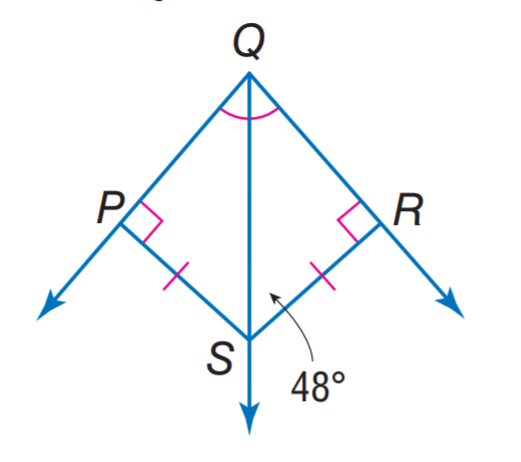Question: Find m \angle P Q S.
Choices:
A. 36
B. 42
C. 48
D. 63
Answer with the letter. Answer: B 